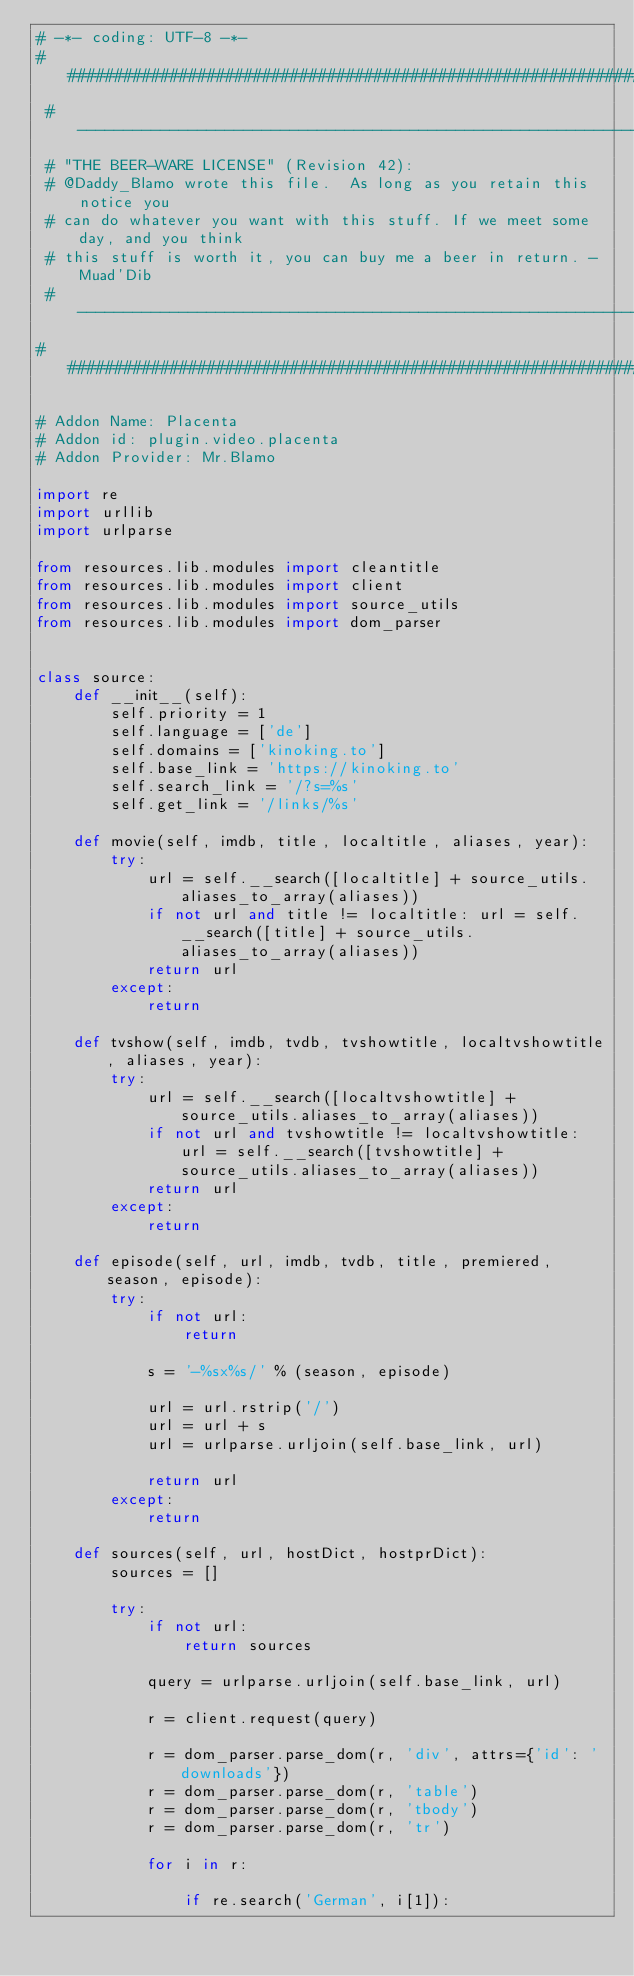<code> <loc_0><loc_0><loc_500><loc_500><_Python_># -*- coding: UTF-8 -*-
#######################################################################
 # ----------------------------------------------------------------------------
 # "THE BEER-WARE LICENSE" (Revision 42):
 # @Daddy_Blamo wrote this file.  As long as you retain this notice you
 # can do whatever you want with this stuff. If we meet some day, and you think
 # this stuff is worth it, you can buy me a beer in return. - Muad'Dib
 # ----------------------------------------------------------------------------
#######################################################################

# Addon Name: Placenta
# Addon id: plugin.video.placenta
# Addon Provider: Mr.Blamo

import re
import urllib
import urlparse

from resources.lib.modules import cleantitle
from resources.lib.modules import client
from resources.lib.modules import source_utils
from resources.lib.modules import dom_parser


class source:
    def __init__(self):
        self.priority = 1
        self.language = ['de']
        self.domains = ['kinoking.to']
        self.base_link = 'https://kinoking.to'
        self.search_link = '/?s=%s'
        self.get_link = '/links/%s'

    def movie(self, imdb, title, localtitle, aliases, year):        
        try:
            url = self.__search([localtitle] + source_utils.aliases_to_array(aliases))
            if not url and title != localtitle: url = self.__search([title] + source_utils.aliases_to_array(aliases))
            return url
        except:
            return

    def tvshow(self, imdb, tvdb, tvshowtitle, localtvshowtitle, aliases, year):
        try:
            url = self.__search([localtvshowtitle] + source_utils.aliases_to_array(aliases))
            if not url and tvshowtitle != localtvshowtitle: url = self.__search([tvshowtitle] + source_utils.aliases_to_array(aliases))
            return url
        except:
            return

    def episode(self, url, imdb, tvdb, title, premiered, season, episode):
        try:
            if not url:
                return

            s = '-%sx%s/' % (season, episode)

            url = url.rstrip('/')
            url = url + s
            url = urlparse.urljoin(self.base_link, url)

            return url
        except:
            return

    def sources(self, url, hostDict, hostprDict):        
        sources = []

        try:
            if not url:
                return sources

            query = urlparse.urljoin(self.base_link, url)

            r = client.request(query)

            r = dom_parser.parse_dom(r, 'div', attrs={'id': 'downloads'})
            r = dom_parser.parse_dom(r, 'table')
            r = dom_parser.parse_dom(r, 'tbody')
            r = dom_parser.parse_dom(r, 'tr')

            for i in r:

                if re.search('German', i[1]):
</code> 